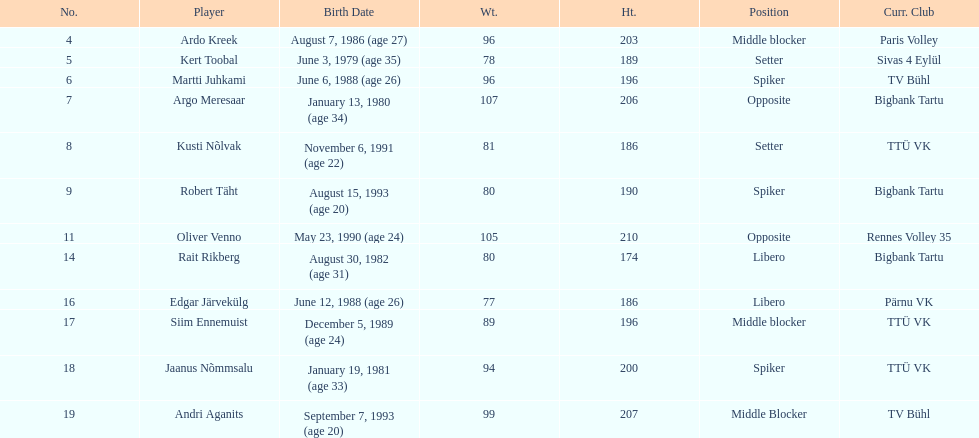How many members of estonia's men's national volleyball team were born in 1988? 2. 